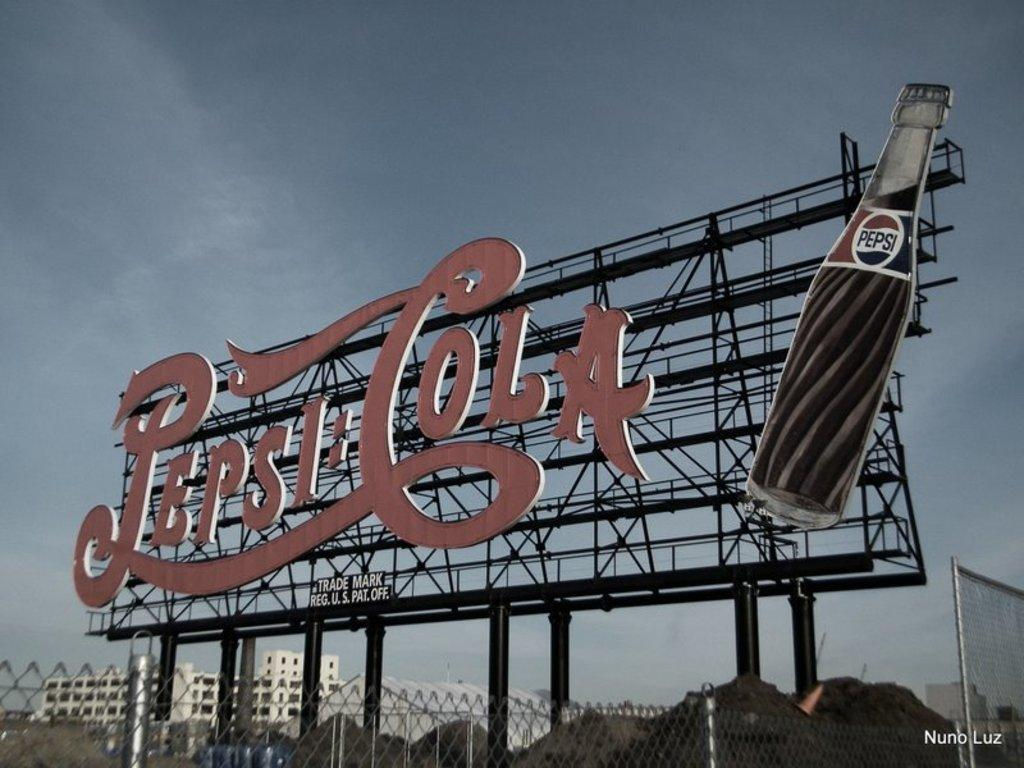<image>
Write a terse but informative summary of the picture. A huge old fashion Pepsi Cola billboard photograph taken by Nuno Luz. 